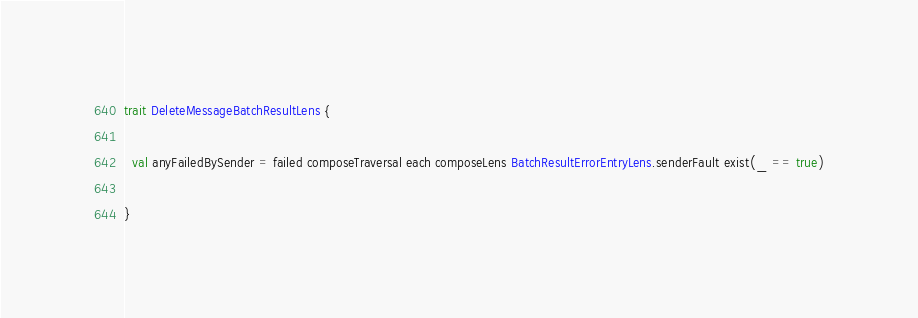Convert code to text. <code><loc_0><loc_0><loc_500><loc_500><_Scala_>trait DeleteMessageBatchResultLens {

  val anyFailedBySender = failed composeTraversal each composeLens BatchResultErrorEntryLens.senderFault exist(_ == true)

}
</code> 